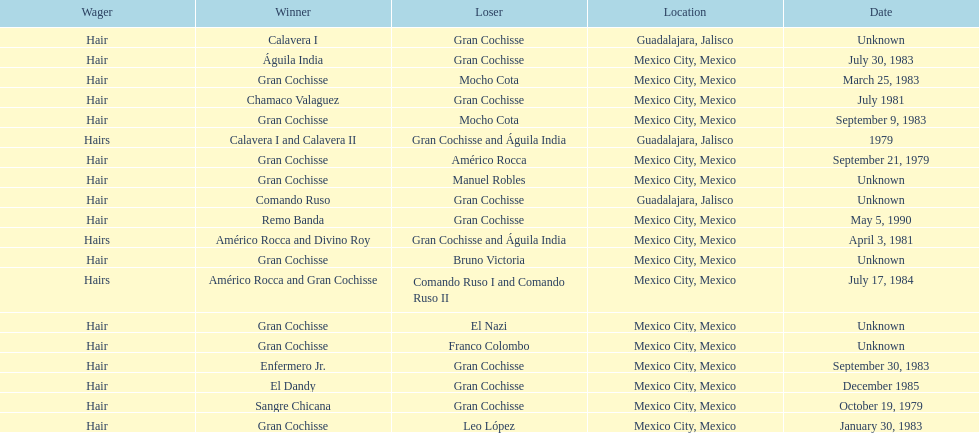When was gran chochisse first match that had a full date on record? September 21, 1979. 